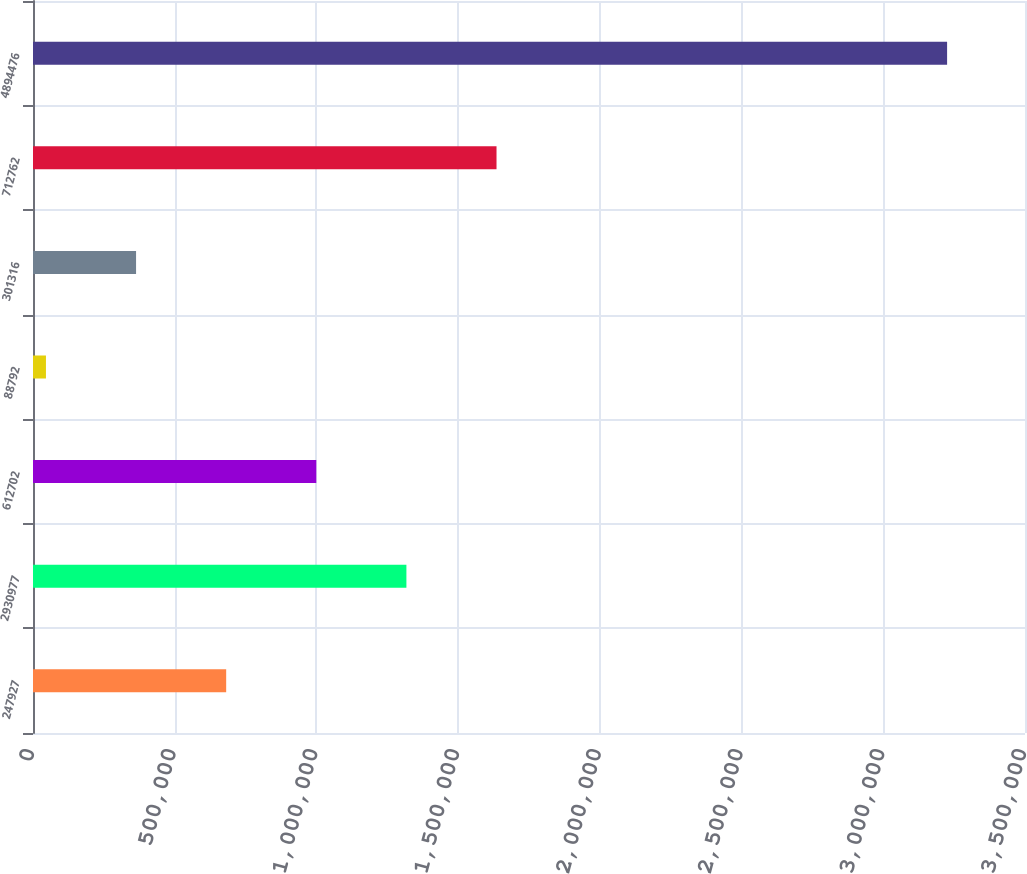Convert chart to OTSL. <chart><loc_0><loc_0><loc_500><loc_500><bar_chart><fcel>247927<fcel>2930977<fcel>612702<fcel>88792<fcel>301316<fcel>712762<fcel>4894476<nl><fcel>681581<fcel>1.31747e+06<fcel>999525<fcel>45693<fcel>363637<fcel>1.63541e+06<fcel>3.22513e+06<nl></chart> 